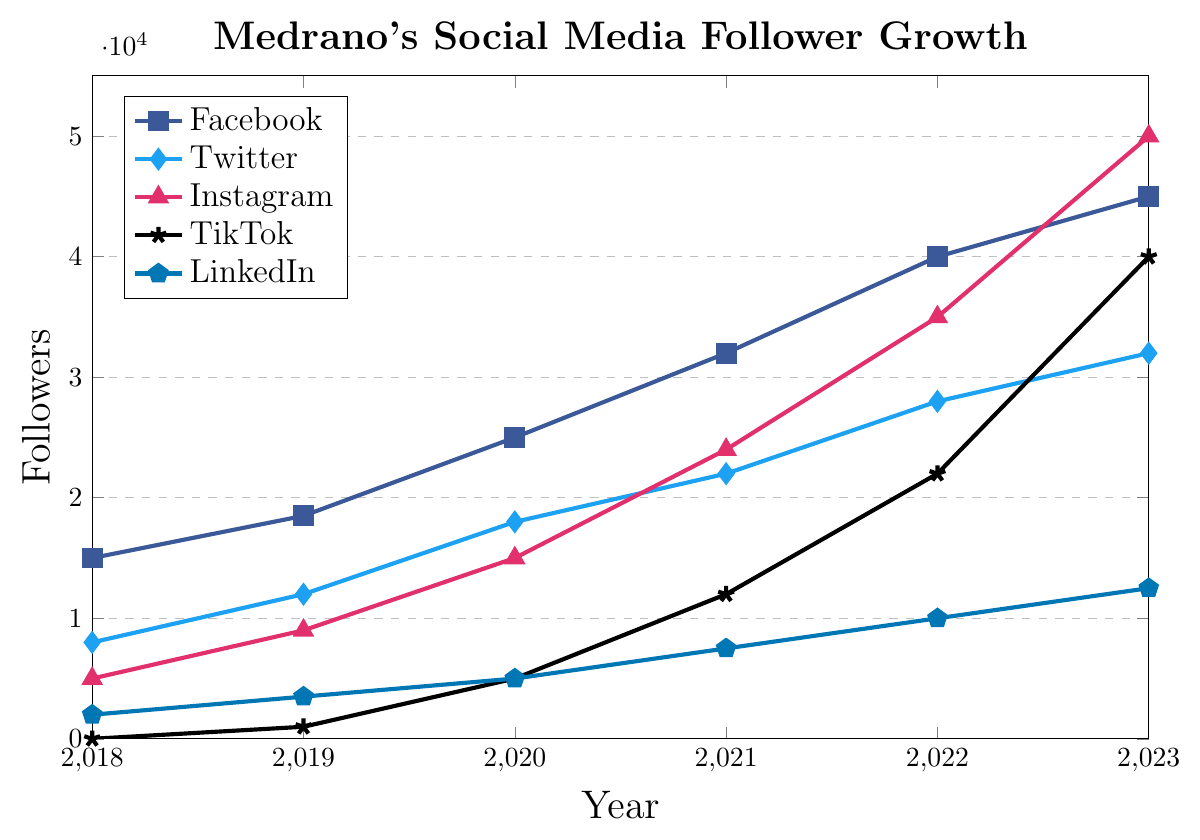Which platform had the highest number of followers in 2023? By observing the values at the point corresponding to 2023 on the plot for each social media platform, Instagram shows the highest number of followers at 50,000.
Answer: Instagram How much did Medrano's TikTok followers grow between 2020 and 2023? The number of TikTok followers in 2020 was 5,000 and in 2023 it was 40,000. The growth can be calculated as 40,000 - 5,000 = 35,000 followers.
Answer: 35,000 Which platform showed the slowest growth between 2021 and 2023? From the plot, we see that the follower count from 2021 to 2023 changed for Facebook from 32,000 to 45,000, for Twitter from 22,000 to 32,000, for Instagram from 24,000 to 50,000, for TikTok from 12,000 to 40,000, and for LinkedIn from 7,500 to 12,500. The smallest change was for LinkedIn: 12,500 - 7,500 = 5,000 followers.
Answer: LinkedIn What is the average number of Instagram followers over the 5-year period? The total number of Instagram followers from 2019 to 2023 is 5,000 + 10,000 + 15,000 + 24,000 + 35,000 + 50,000 = 139,000. Dividing by 6, the average is 139,000 / 6 ≈ 23,167 followers.
Answer: 23,167 Which year did Medrano gain the most followers on Facebook? By analyzing the data points for Facebook, the yearly follower growth is as follows: 2019 - 3,500, 2020 - 6,500, 2021 - 7,000, 2022 - 8,000, 2023 - 5,000. The year with the most gain is 2022 with an increase of 8,000 followers.
Answer: 2022 How many more Twitter followers did Medrano have in 2023 compared to 2018? The number of Twitter followers in 2018 was 8,000, and in 2023 it was 32,000. The difference is 32,000 - 8,000 = 24,000 followers.
Answer: 24,000 What was the total follower count across all platforms in 2022? Summing Medrano’s followers in 2022 across all platforms gives 40,000 (Facebook) + 28,000 (Twitter) + 35,000 (Instagram) + 22,000 (TikTok) + 10,000 (LinkedIn) = 135,000 followers.
Answer: 135,000 Which platform had equal follower growth in two consecutive years? By examining the plot data, Facebook had equal growth of 7,500 followers both from 2021 to 2022 and from 2022 to 2023.
Answer: Facebook 